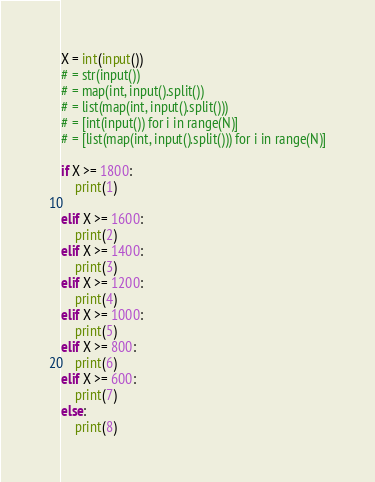Convert code to text. <code><loc_0><loc_0><loc_500><loc_500><_Python_>X = int(input())
# = str(input())
# = map(int, input().split())
# = list(map(int, input().split()))
# = [int(input()) for i in range(N)]
# = [list(map(int, input().split())) for i in range(N)]

if X >= 1800:
    print(1)

elif X >= 1600:
    print(2)
elif X >= 1400:
    print(3)
elif X >= 1200:
    print(4)
elif X >= 1000:
    print(5)
elif X >= 800:
    print(6)
elif X >= 600:
    print(7)
else:
    print(8)
</code> 